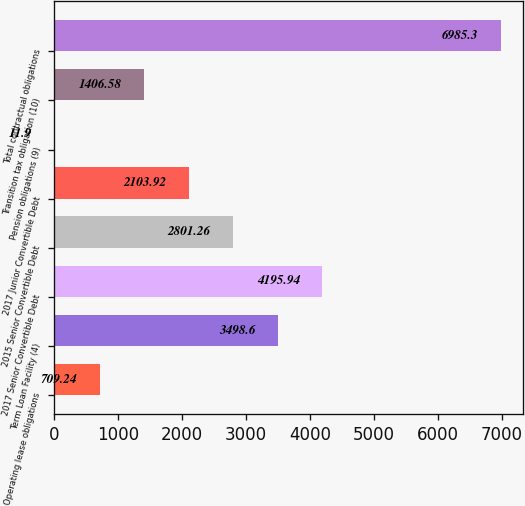Convert chart. <chart><loc_0><loc_0><loc_500><loc_500><bar_chart><fcel>Operating lease obligations<fcel>Term Loan Facility (4)<fcel>2017 Senior Convertible Debt<fcel>2015 Senior Convertible Debt<fcel>2017 Junior Convertible Debt<fcel>Pension obligations (9)<fcel>Transition tax obligation (10)<fcel>Total contractual obligations<nl><fcel>709.24<fcel>3498.6<fcel>4195.94<fcel>2801.26<fcel>2103.92<fcel>11.9<fcel>1406.58<fcel>6985.3<nl></chart> 